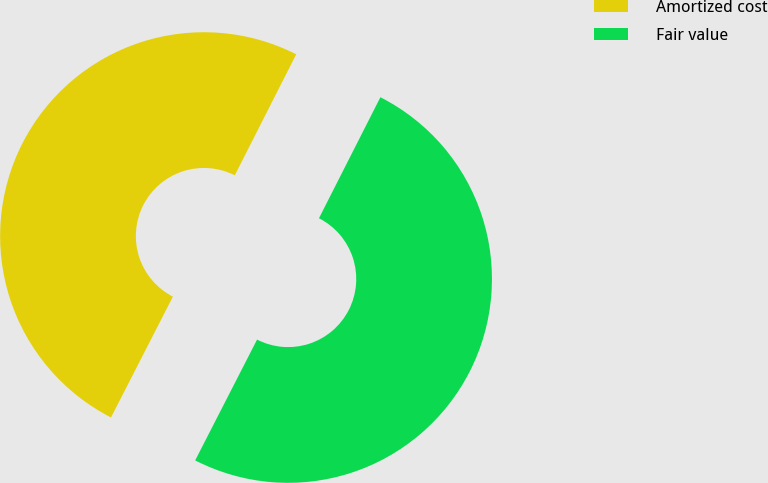Convert chart. <chart><loc_0><loc_0><loc_500><loc_500><pie_chart><fcel>Amortized cost<fcel>Fair value<nl><fcel>49.94%<fcel>50.06%<nl></chart> 